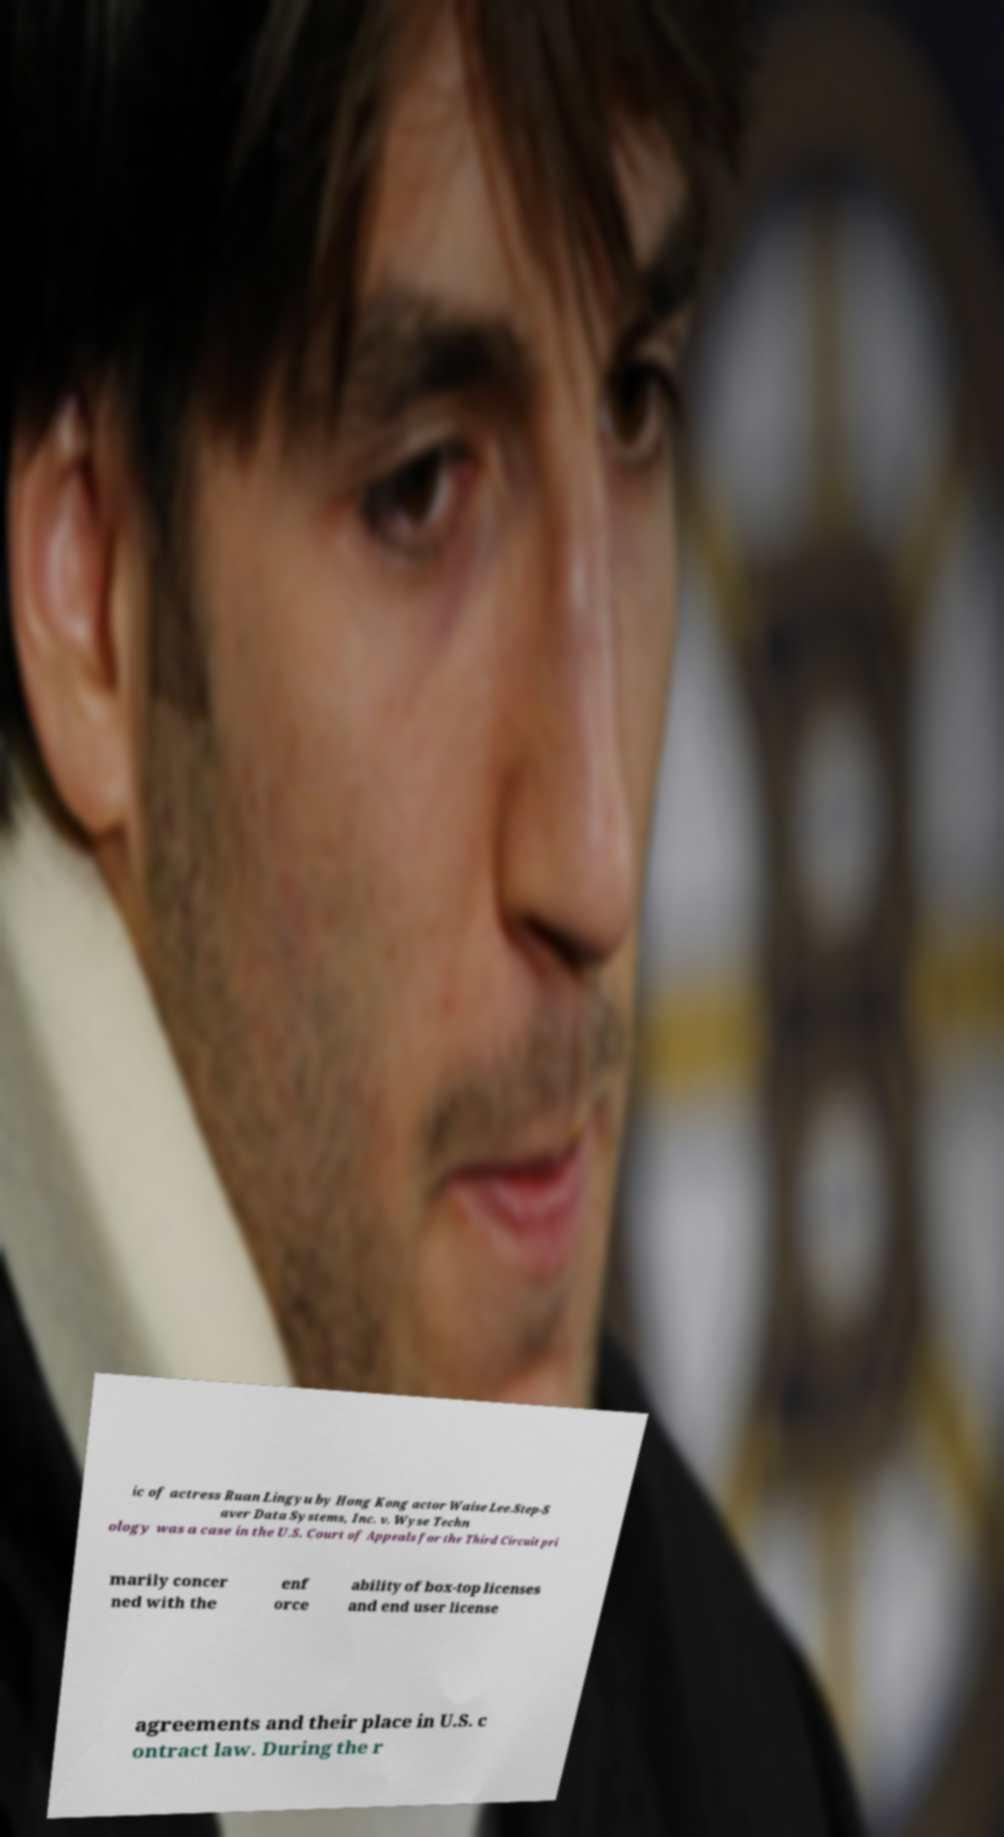Please read and relay the text visible in this image. What does it say? ic of actress Ruan Lingyu by Hong Kong actor Waise Lee.Step-S aver Data Systems, Inc. v. Wyse Techn ology was a case in the U.S. Court of Appeals for the Third Circuit pri marily concer ned with the enf orce ability of box-top licenses and end user license agreements and their place in U.S. c ontract law. During the r 